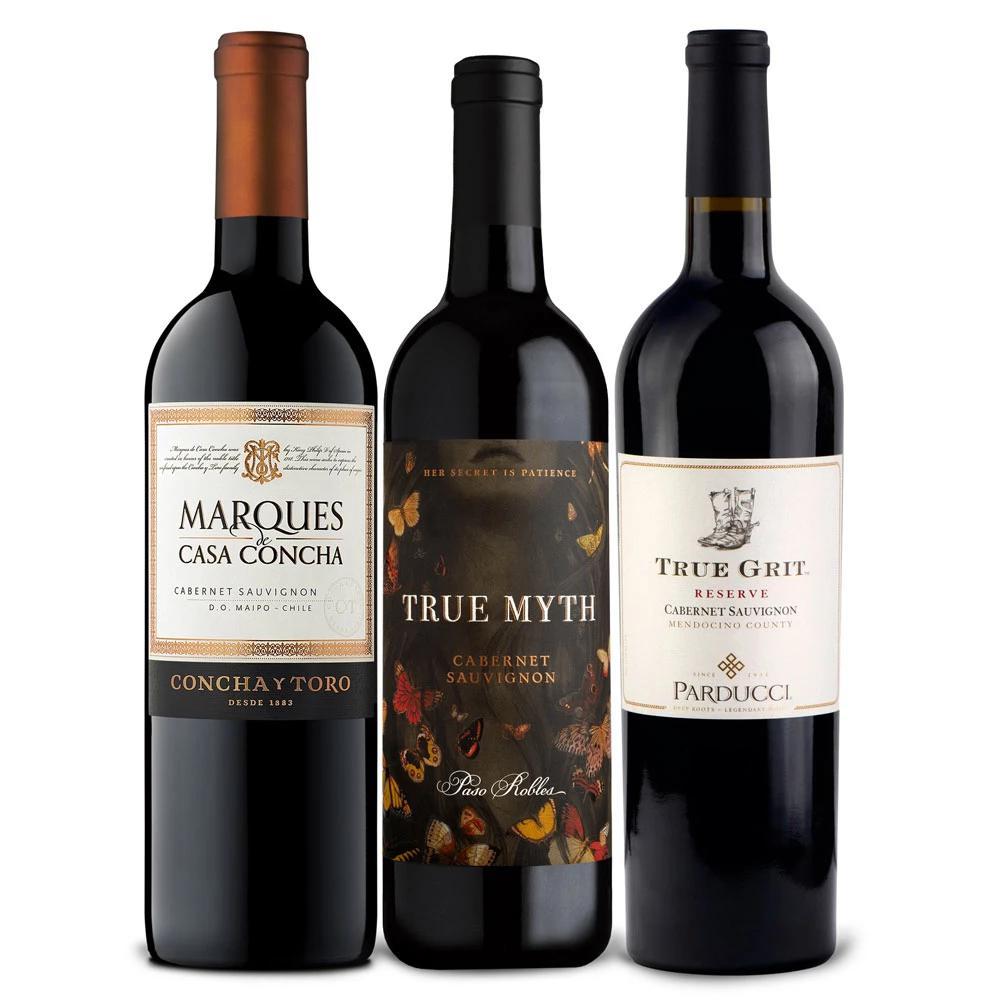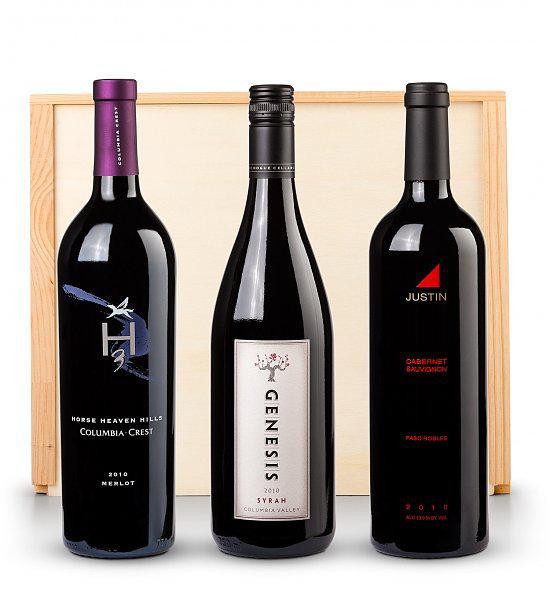The first image is the image on the left, the second image is the image on the right. For the images displayed, is the sentence "The right image contains exactly three wine bottles in a horizontal row." factually correct? Answer yes or no. Yes. The first image is the image on the left, the second image is the image on the right. Considering the images on both sides, is "One image shows exactly three bottles, all with the same shape and same bottle color." valid? Answer yes or no. Yes. 